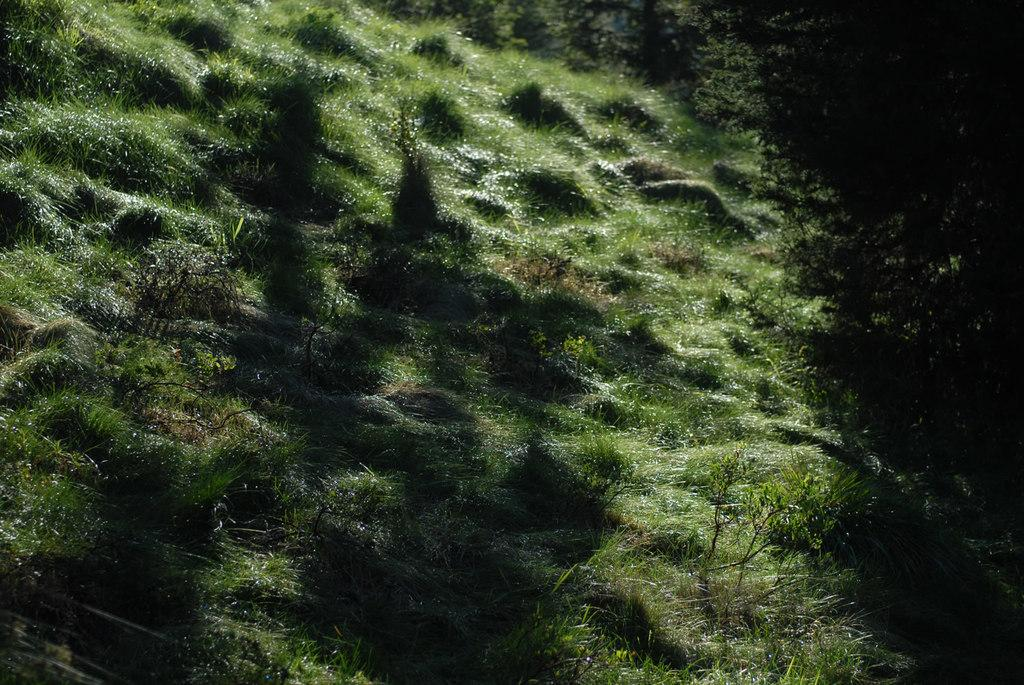What type of vegetation can be seen in the image? There is grass and plants in the image. Can you describe the natural environment depicted in the image? The image features a grassy area with plants. How many lizards are crawling on the wool in the image? There are no lizards or wool present in the image. 